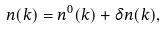Convert formula to latex. <formula><loc_0><loc_0><loc_500><loc_500>n ( k ) = n ^ { 0 } ( k ) + \delta n ( k ) ,</formula> 